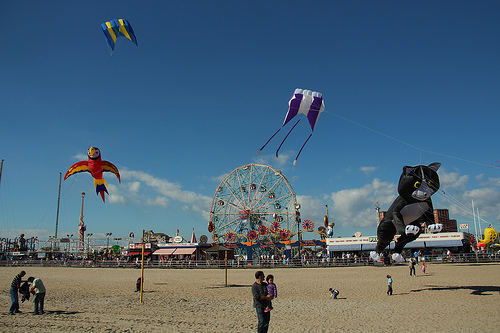<image>
Can you confirm if the man is under the kitty? No. The man is not positioned under the kitty. The vertical relationship between these objects is different. Is the cat in the sky? Yes. The cat is contained within or inside the sky, showing a containment relationship. 